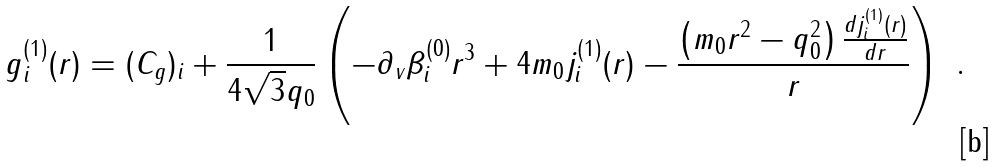Convert formula to latex. <formula><loc_0><loc_0><loc_500><loc_500>g _ { i } ^ { ( 1 ) } ( r ) = ( C _ { g } ) _ { i } + \frac { 1 } { 4 \sqrt { 3 } q _ { 0 } } \left ( - \partial _ { v } \beta _ { i } ^ { ( 0 ) } r ^ { 3 } + 4 m _ { 0 } j _ { i } ^ { ( 1 ) } ( r ) - \frac { \left ( m _ { 0 } r ^ { 2 } - q _ { 0 } ^ { 2 } \right ) \frac { d j _ { i } ^ { ( 1 ) } ( r ) } { d r } } { r } \right ) \ .</formula> 